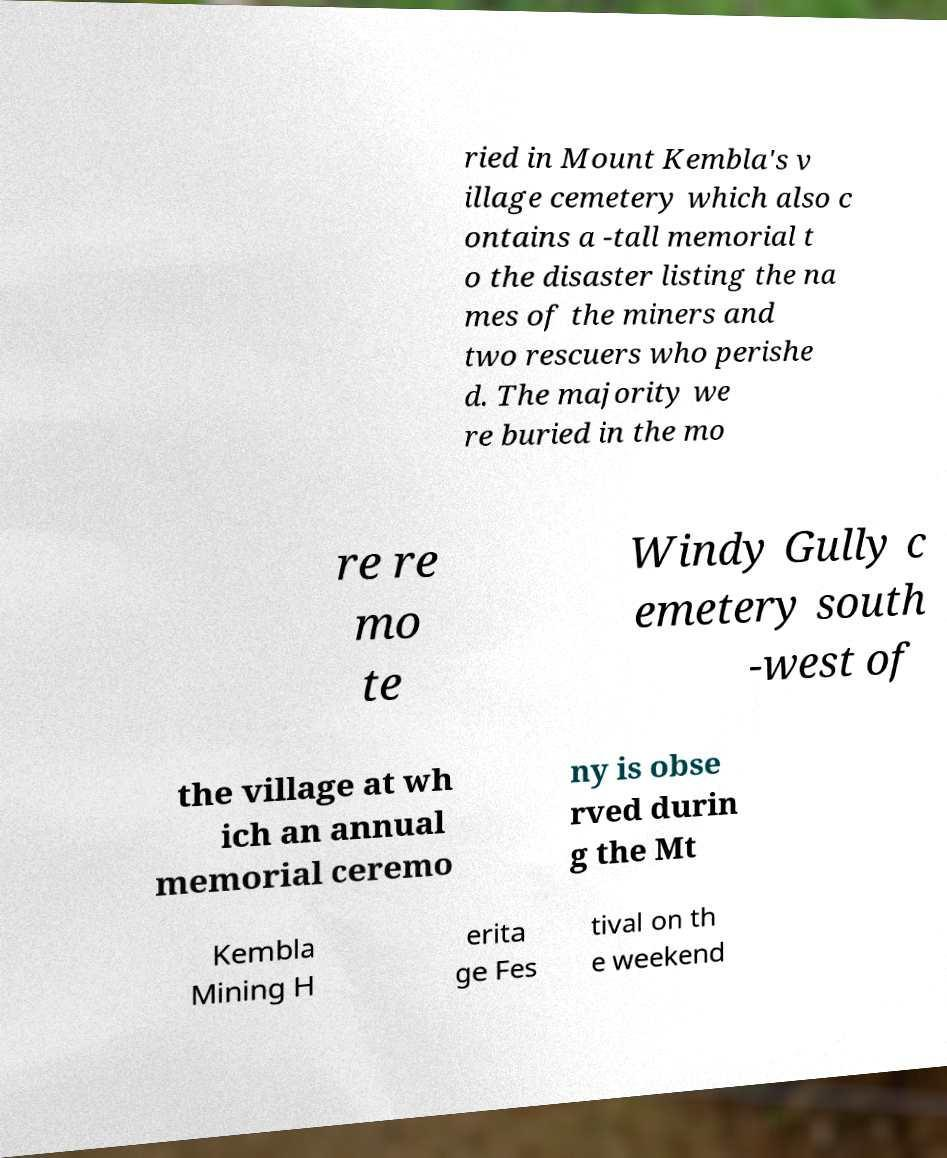Can you read and provide the text displayed in the image?This photo seems to have some interesting text. Can you extract and type it out for me? ried in Mount Kembla's v illage cemetery which also c ontains a -tall memorial t o the disaster listing the na mes of the miners and two rescuers who perishe d. The majority we re buried in the mo re re mo te Windy Gully c emetery south -west of the village at wh ich an annual memorial ceremo ny is obse rved durin g the Mt Kembla Mining H erita ge Fes tival on th e weekend 